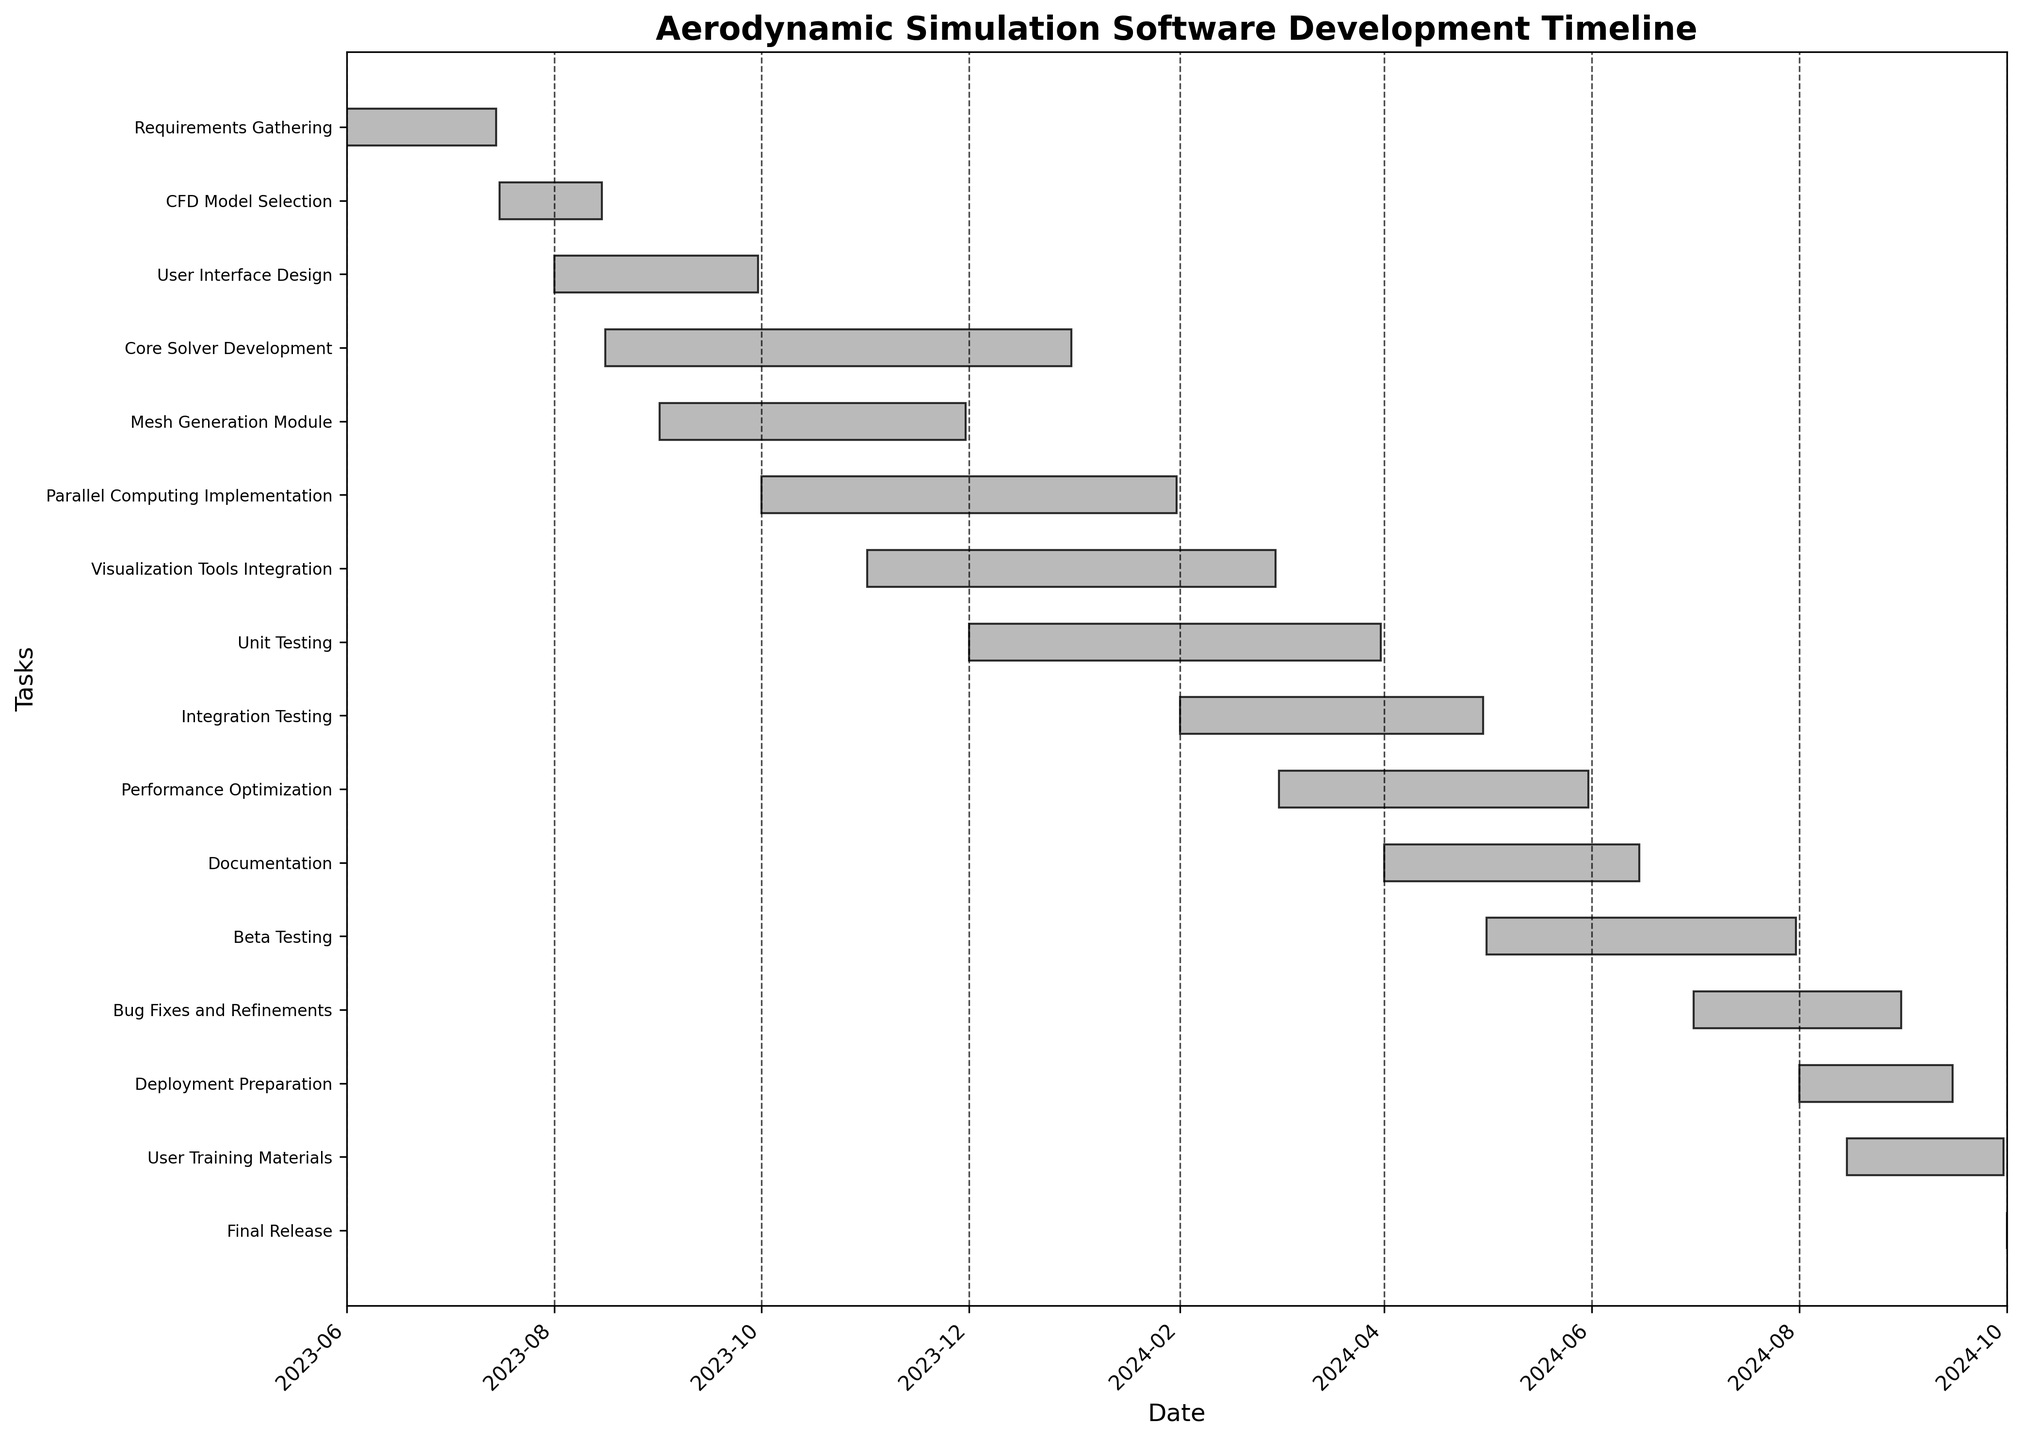What's the title of the Gantt chart? The title of the Gantt chart is the text most prominently displayed at the top of the figure, often in a larger and bold font. The title serves as a summary of what the chart represents. In this figure, the title is "Aerodynamic Simulation Software Development Timeline."
Answer: Aerodynamic Simulation Software Development Timeline How many tasks are there in the project timeline? The number of tasks can be counted by looking at the number of horizontal bars or the number of labels on the y-axis. In the figure, there are 16 tasks listed on the y-axis.
Answer: 16 During which months does the "Core Solver Development" phase occur? Locate "Core Solver Development" on the y-axis, then trace horizontally to see the start and end dates along the x-axis. The start date is August 16, 2023, and the end date is December 31, 2023, covering the months of August, September, October, November, and December.
Answer: August to December 2023 Which task has the earliest start date? Identify the task that begins at the furthest left point on the x-axis. In this figure, "Requirements Gathering" starts on June 1, 2023, which is the earliest start date.
Answer: Requirements Gathering Which task has the latest end date? Locate the task that extends the furthest to the right on the x-axis. "Bug Fixes and Refinements" ends on August 31, 2024, making it the task with the latest end date.
Answer: Bug Fixes and Refinements Which phase has the longest duration? Compare the lengths of the horizontal bars. The length is determined by the difference between the start and end dates. "Core Solver Development" has the longest bar, starting on August 16, 2023, and ending on December 31, 2023.
Answer: Core Solver Development Which tasks overlap with "Parallel Computing Implementation"? Identify the start and end dates for "Parallel Computing Implementation" (October 1, 2023, to January 31, 2024) and see which other tasks have bars that fall within or cross these dates. The tasks that overlap are "Core Solver Development," "Mesh Generation Module," "Visualization Tools Integration," "Unit Testing," and "Performance Optimization."
Answer: Core Solver Development, Mesh Generation Module, Visualization Tools Integration, Unit Testing, Performance Optimization What is the total duration of the "Performance Optimization" phase? Calculate the difference between the start and end dates of the task. "Performance Optimization" starts on March 1, 2024, and ends on May 31, 2024, a total of 3 months.
Answer: 3 months How many tasks are active during February 2024? Identify the tasks that have bars extending into or starting in February 2024. The tasks are "Parallel Computing Implementation," "Visualization Tools Integration," "Unit Testing," and "Integration Testing."
Answer: 4 Which tasks directly follow "Requirements Gathering"? Look for tasks that start immediately after the end date of "Requirements Gathering" on July 15, 2023. The task that follows is "CFD Model Selection," which starts on July 16, 2023.
Answer: CFD Model Selection 